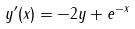<formula> <loc_0><loc_0><loc_500><loc_500>y ^ { \prime } ( x ) = - 2 y + e ^ { - x }</formula> 